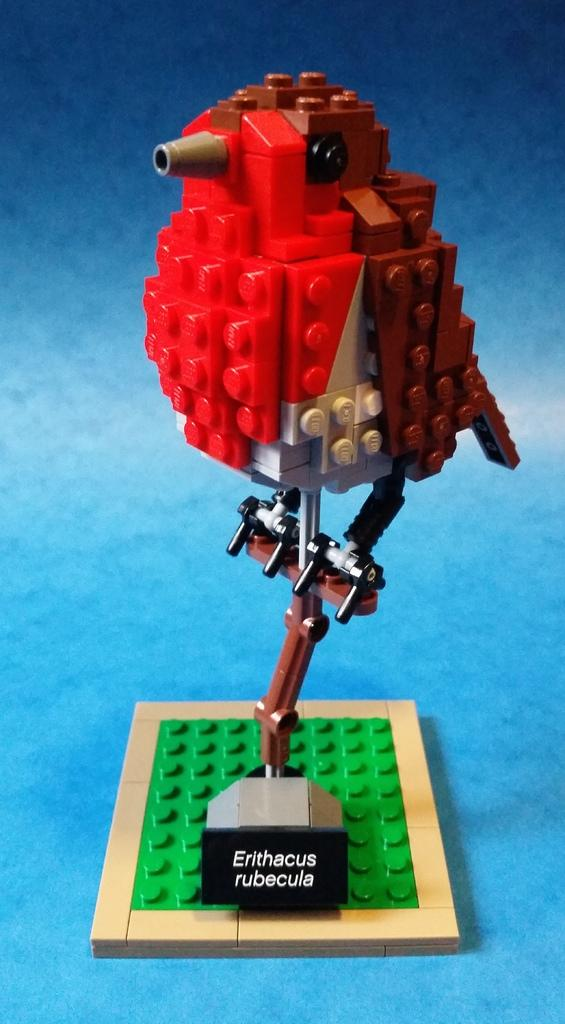What type of toy is present in the image? There is a toy made of building blocks in the image. What is the toy placed on? The toy is placed on a blue platform. What type of pain can be seen on the toy's face in the image? There is no indication of a toy having a face or experiencing pain in the image. 